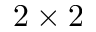<formula> <loc_0><loc_0><loc_500><loc_500>2 \times 2</formula> 